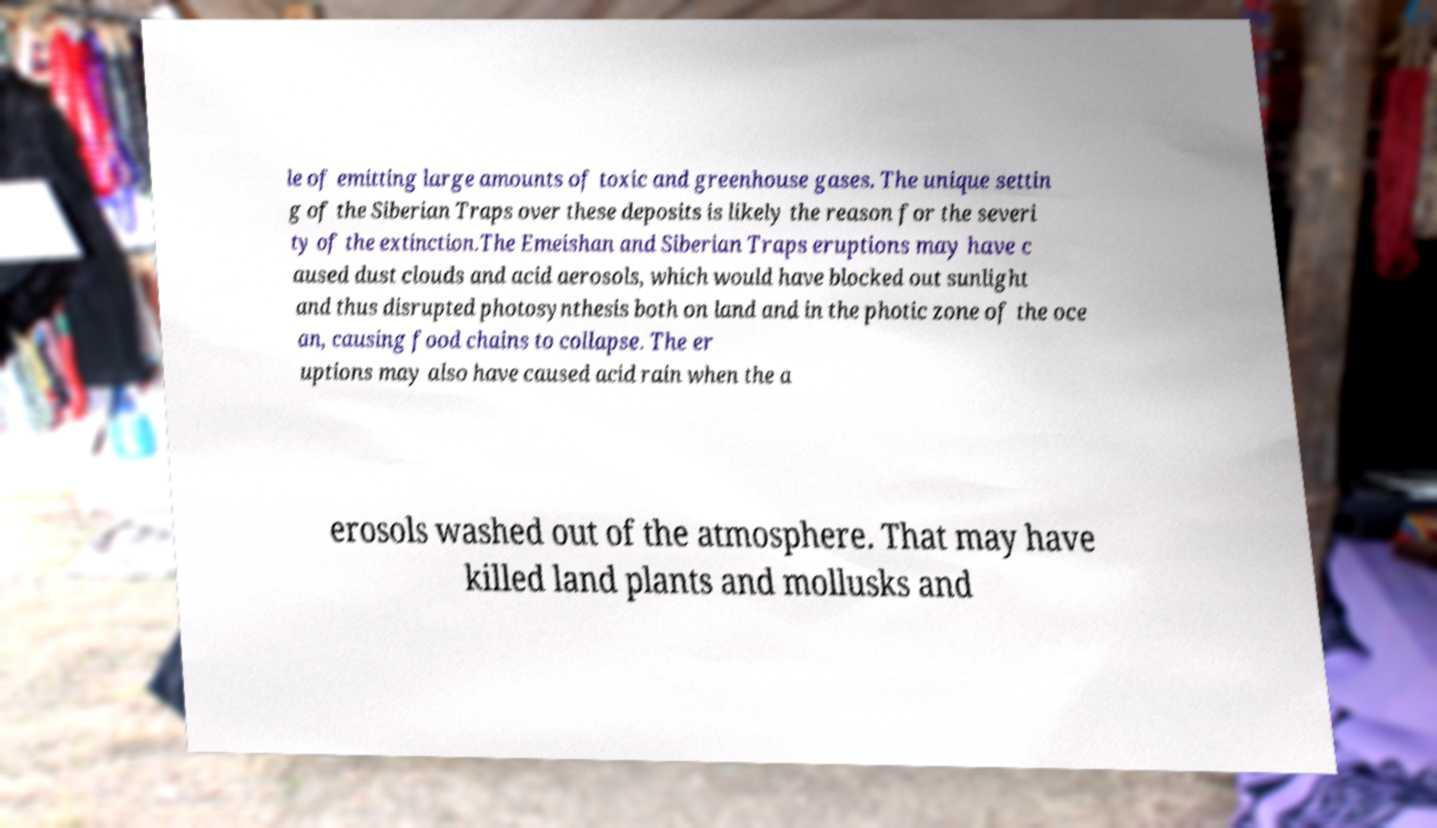There's text embedded in this image that I need extracted. Can you transcribe it verbatim? le of emitting large amounts of toxic and greenhouse gases. The unique settin g of the Siberian Traps over these deposits is likely the reason for the severi ty of the extinction.The Emeishan and Siberian Traps eruptions may have c aused dust clouds and acid aerosols, which would have blocked out sunlight and thus disrupted photosynthesis both on land and in the photic zone of the oce an, causing food chains to collapse. The er uptions may also have caused acid rain when the a erosols washed out of the atmosphere. That may have killed land plants and mollusks and 